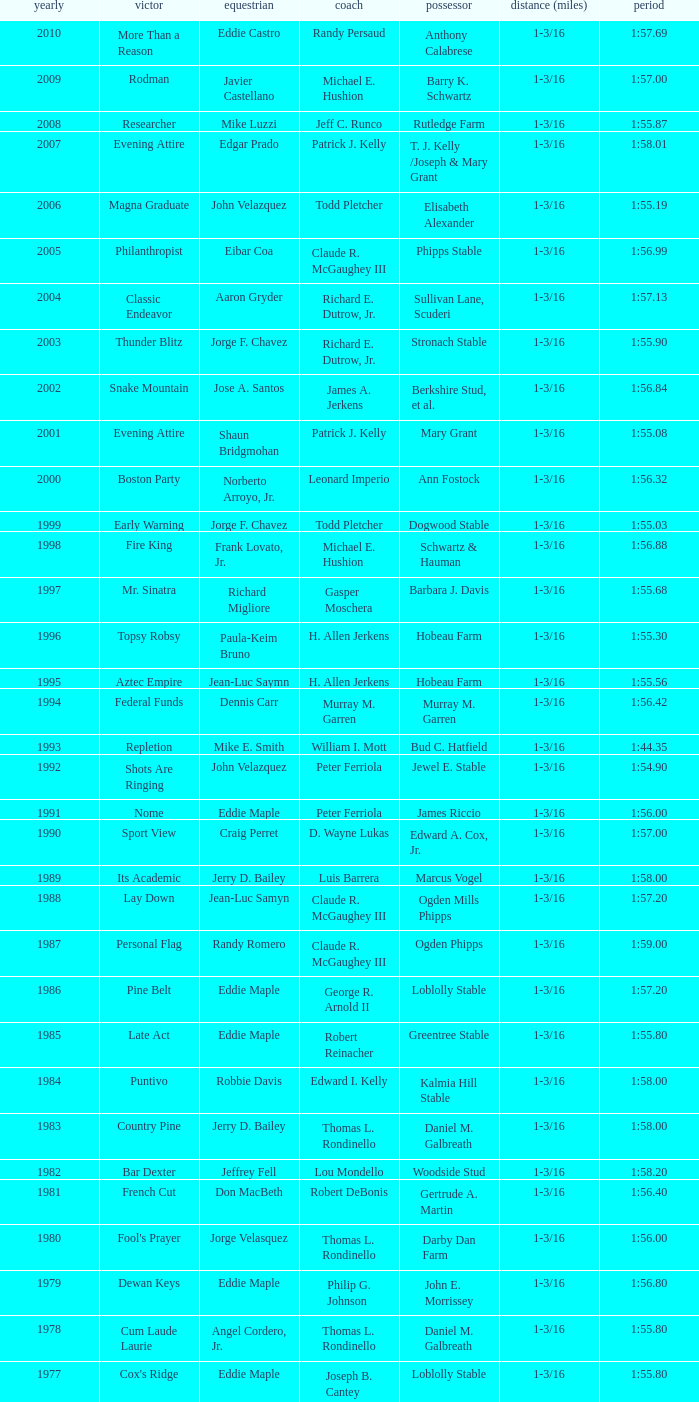What was the winning time for the winning horse, Kentucky ii? 1:38.80. 